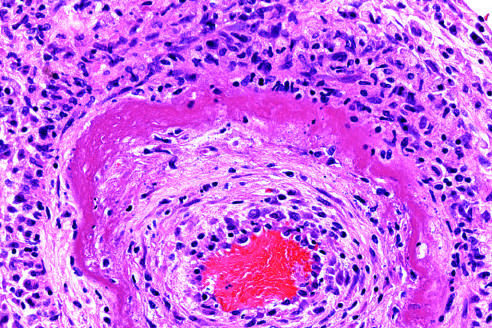what shows a circumferential bright pink area of necrosis with protein deposition and inflammation?
Answer the question using a single word or phrase. The wall of the artery 